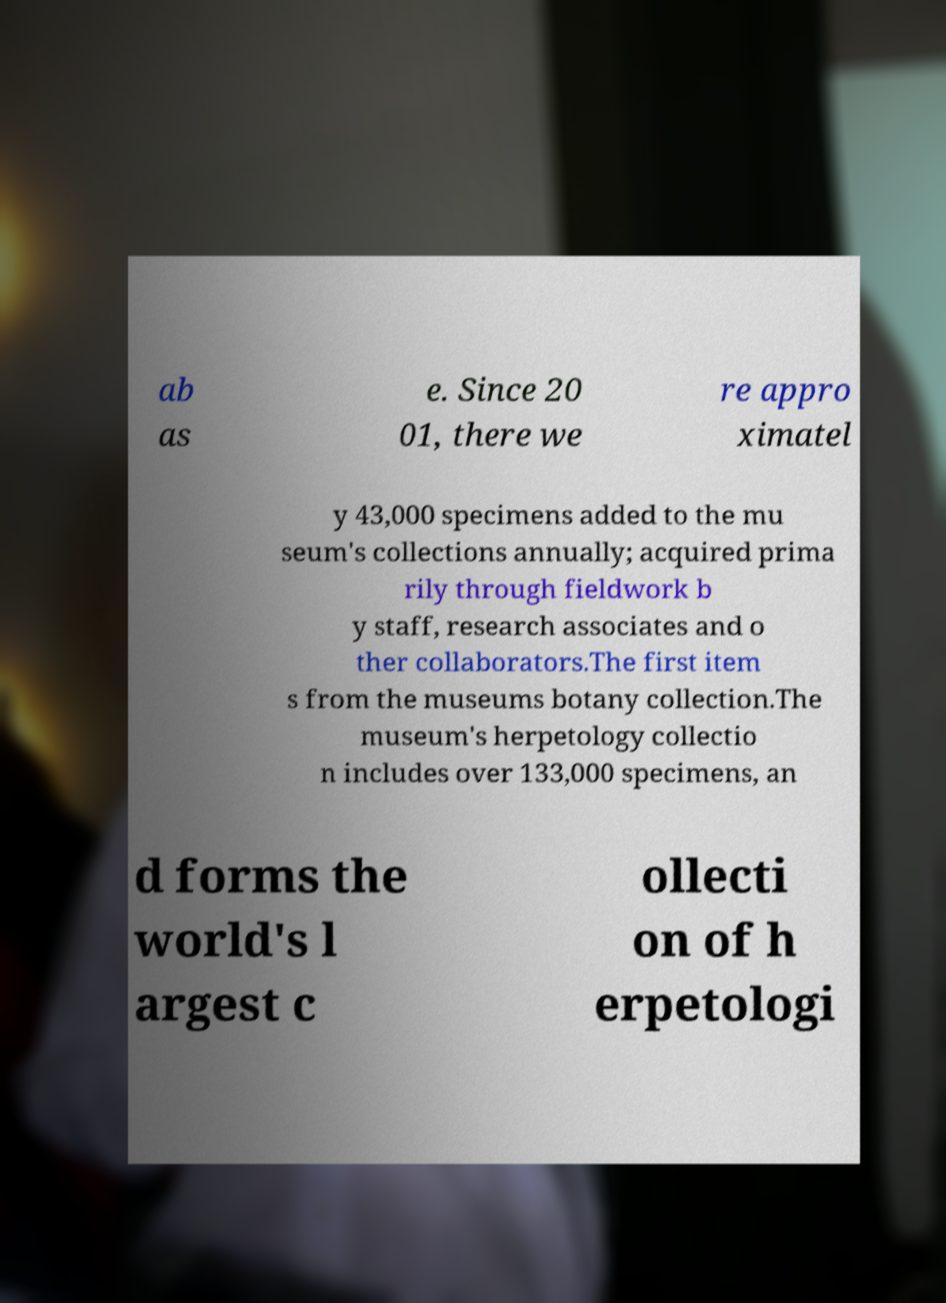Could you extract and type out the text from this image? ab as e. Since 20 01, there we re appro ximatel y 43,000 specimens added to the mu seum's collections annually; acquired prima rily through fieldwork b y staff, research associates and o ther collaborators.The first item s from the museums botany collection.The museum's herpetology collectio n includes over 133,000 specimens, an d forms the world's l argest c ollecti on of h erpetologi 